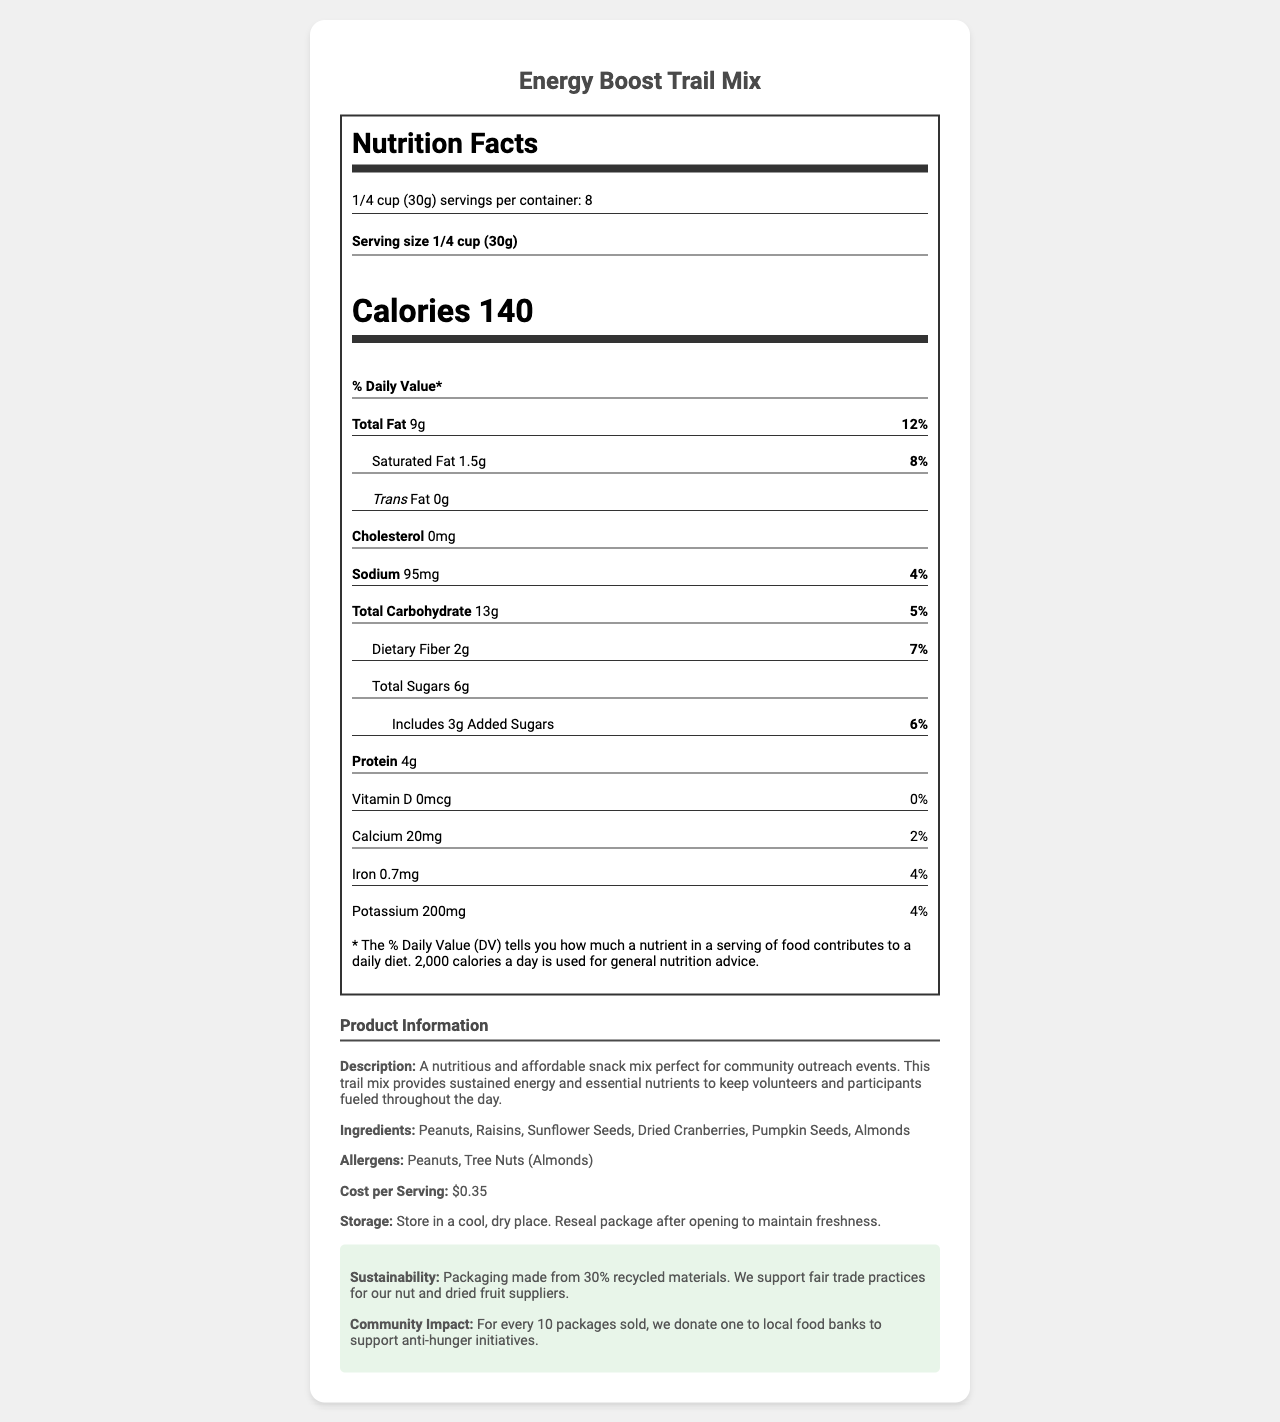what is the serving size? The serving size is explicitly mentioned as "1/4 cup (30g)" in the nutrition label.
Answer: 1/4 cup (30g) how many servings are there per container? The nutrition label mentions "servings per container: 8" directly.
Answer: 8 what is the amount of total fat per serving? The total fat per serving is listed as "9g" under the nutrient information.
Answer: 9g what allergens are present in this product? Allergens are explicitly listed as "Peanuts, Tree Nuts (Almonds)" in the product information section.
Answer: Peanuts, Tree Nuts (Almonds) how many calories are in one serving of this product? The calories per serving is mentioned as "Calories 140" on the nutrition facts label.
Answer: 140 what is the cost per serving of the Energy Boost Trail Mix? The cost per serving is clearly stated as "$0.35" in the product information section.
Answer: $0.35 how much Vitamin D does this product contain? The nutrient information lists Vitamin D content as "0mcg".
Answer: 0mcg how does the product contribute to community impact? The community impact details are provided in the sustainability section: "For every 10 packages sold, we donate one to local food banks to support anti-hunger initiatives."
Answer: For every 10 packages sold, one is donated to local food banks to support anti-hunger initiatives. how should this product be stored? The storage instructions specify "Store in a cool, dry place. Reseal package after opening to maintain freshness."
Answer: Store in a cool, dry place. Reseal package after opening to maintain freshness. which ingredient is not listed in the Energy Boost Trail Mix? A. Peanuts B. Raisins C. Walnuts The ingredients listed are "Peanuts, Raisins, Sunflower Seeds, Dried Cranberries, Pumpkin Seeds, Almonds." Walnuts are not mentioned.
Answer: C what percentage of the daily value of saturated fat does one serving contain? The saturated fat amount and its daily value are listed as "1.5g (8%)" in the nutrient information.
Answer: 8% does the product contain any trans fat? The nutrition facts label specifies "Trans Fat 0g," indicating there is no trans fat in the product.
Answer: No what are the main reasons this product is recommended for community outreach events? The product description and sustainability notes detail the reasons: it provides energy and nutrients, is affordable, packaged sustainably, and supports anti-hunger initiatives.
Answer: Provides sustained energy and essential nutrients at an affordable cost, supports sustainability, and community impact initiatives. what are the main ingredients in the Energy Boost Trail Mix? The ingredients listed in the product information section are "Peanuts, Raisins, Sunflower Seeds, Dried Cranberries, Pumpkin Seeds, Almonds."
Answer: Peanuts, Raisins, Sunflower Seeds, Dried Cranberries, Pumpkin Seeds, Almonds what percentage of the daily value of sodium does one serving contribute? The sodium content and its daily value are listed as "95mg (4%)" on the nutrition facts label.
Answer: 4% how many grams of added sugars are there per serving? The added sugars amount is listed as "Includes 3g Added Sugars"
Answer: 3g who are the nut and dried fruit suppliers for this product? The document mentions support for fair trade practices but does not specify the specific suppliers.
Answer: Not enough information describe the primary purpose and benefits of the Energy Boost Trail Mix document. This document encompasses various sections including nutrition facts, product description, ingredient list, allergen information, cost per serving, storage instructions, and sustainability notes, all of which highlight the benefits and suitability of the product for community outreach events and its impact on the community.
Answer: The document provides comprehensive nutritional information about an affordable, high-energy snack ideal for community outreach events. It covers serving size, calories, and nutrient breakdown, along with product details like ingredients, allergens, cost, storage instructions, and sustainability practices, which all emphasize the nutritional value, affordability, and community impact of the product. 